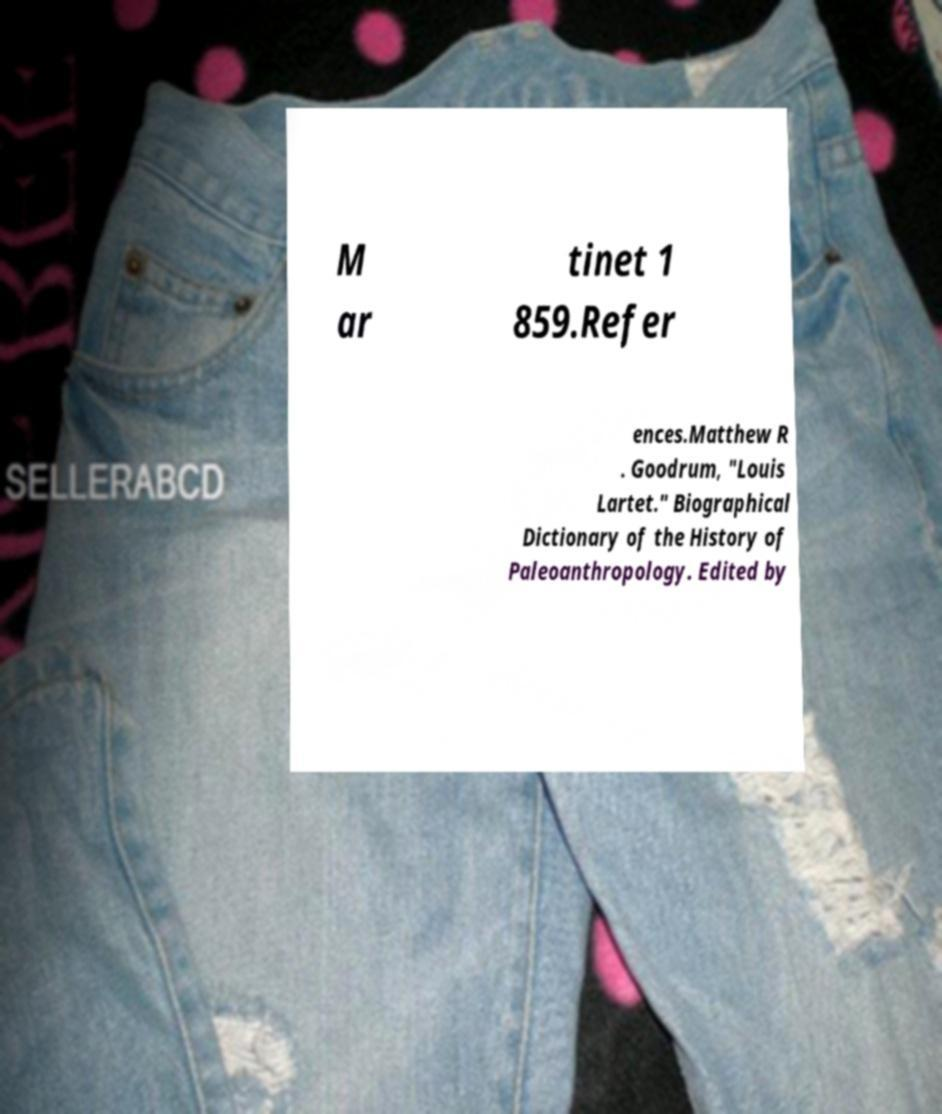Can you read and provide the text displayed in the image?This photo seems to have some interesting text. Can you extract and type it out for me? M ar tinet 1 859.Refer ences.Matthew R . Goodrum, "Louis Lartet." Biographical Dictionary of the History of Paleoanthropology. Edited by 